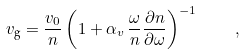Convert formula to latex. <formula><loc_0><loc_0><loc_500><loc_500>v _ { \text {g} } = \frac { v _ { 0 } } { n } \left ( 1 + \alpha _ { v } \, \frac { \omega } { n } \frac { \partial n } { \partial \omega } \right ) ^ { - 1 } \quad ,</formula> 